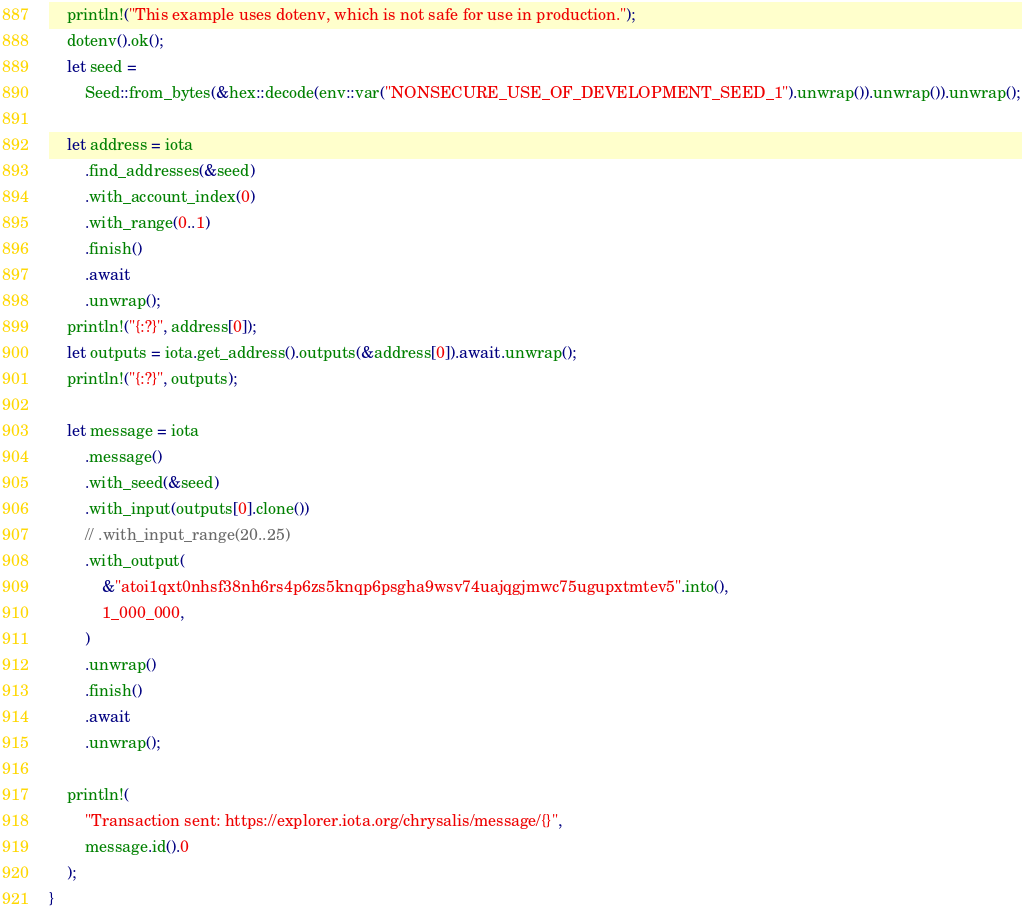Convert code to text. <code><loc_0><loc_0><loc_500><loc_500><_Rust_>    println!("This example uses dotenv, which is not safe for use in production.");
    dotenv().ok();
    let seed =
        Seed::from_bytes(&hex::decode(env::var("NONSECURE_USE_OF_DEVELOPMENT_SEED_1").unwrap()).unwrap()).unwrap();

    let address = iota
        .find_addresses(&seed)
        .with_account_index(0)
        .with_range(0..1)
        .finish()
        .await
        .unwrap();
    println!("{:?}", address[0]);
    let outputs = iota.get_address().outputs(&address[0]).await.unwrap();
    println!("{:?}", outputs);

    let message = iota
        .message()
        .with_seed(&seed)
        .with_input(outputs[0].clone())
        // .with_input_range(20..25)
        .with_output(
            &"atoi1qxt0nhsf38nh6rs4p6zs5knqp6psgha9wsv74uajqgjmwc75ugupxtmtev5".into(),
            1_000_000,
        )
        .unwrap()
        .finish()
        .await
        .unwrap();

    println!(
        "Transaction sent: https://explorer.iota.org/chrysalis/message/{}",
        message.id().0
    );
}
</code> 